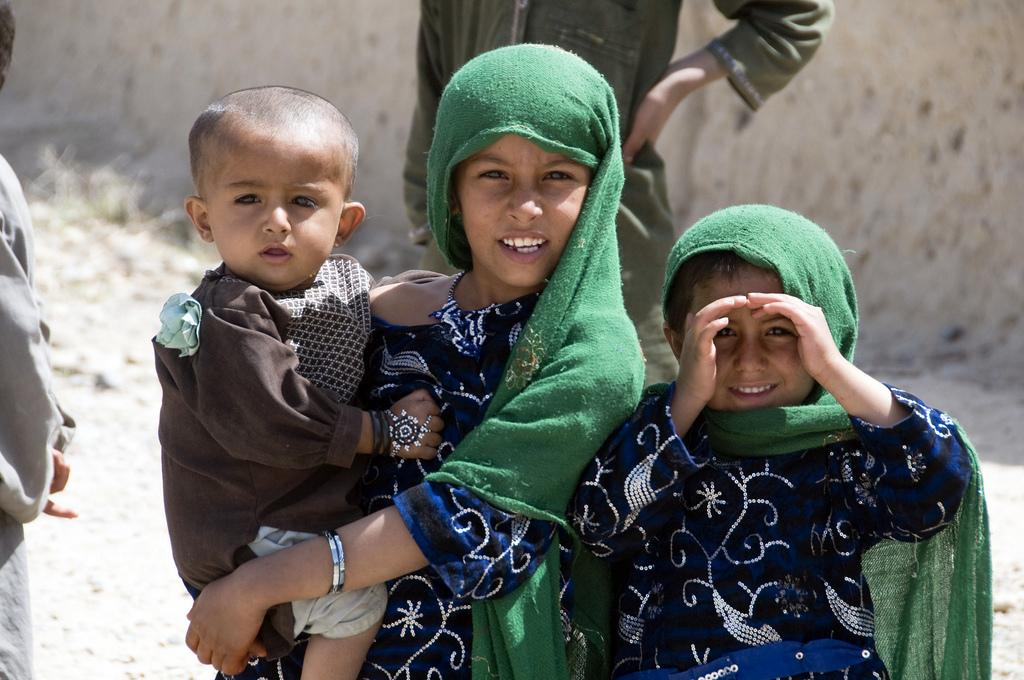Who is present in the image? There are kids in the image. What are the kids wearing? The kids are wearing clothes. Can you describe the background of the image? The background of the image is blurred. What type of veil can be seen on the stove in the image? There is no veil or stove present in the image; it features kids wearing clothes with a blurred background. 